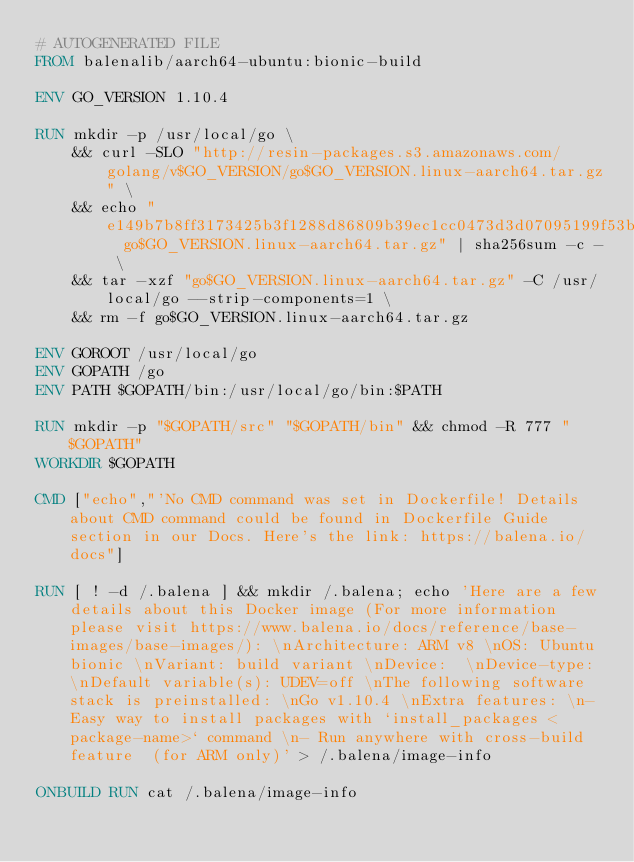Convert code to text. <code><loc_0><loc_0><loc_500><loc_500><_Dockerfile_># AUTOGENERATED FILE
FROM balenalib/aarch64-ubuntu:bionic-build

ENV GO_VERSION 1.10.4

RUN mkdir -p /usr/local/go \
	&& curl -SLO "http://resin-packages.s3.amazonaws.com/golang/v$GO_VERSION/go$GO_VERSION.linux-aarch64.tar.gz" \
	&& echo "e149b7b8ff3173425b3f1288d86809b39ec1cc0473d3d07095199f53bc02ff48  go$GO_VERSION.linux-aarch64.tar.gz" | sha256sum -c - \
	&& tar -xzf "go$GO_VERSION.linux-aarch64.tar.gz" -C /usr/local/go --strip-components=1 \
	&& rm -f go$GO_VERSION.linux-aarch64.tar.gz

ENV GOROOT /usr/local/go
ENV GOPATH /go
ENV PATH $GOPATH/bin:/usr/local/go/bin:$PATH

RUN mkdir -p "$GOPATH/src" "$GOPATH/bin" && chmod -R 777 "$GOPATH"
WORKDIR $GOPATH

CMD ["echo","'No CMD command was set in Dockerfile! Details about CMD command could be found in Dockerfile Guide section in our Docs. Here's the link: https://balena.io/docs"]

RUN [ ! -d /.balena ] && mkdir /.balena; echo 'Here are a few details about this Docker image (For more information please visit https://www.balena.io/docs/reference/base-images/base-images/): \nArchitecture: ARM v8 \nOS: Ubuntu bionic \nVariant: build variant \nDevice:  \nDevice-type: \nDefault variable(s): UDEV=off \nThe following software stack is preinstalled: \nGo v1.10.4 \nExtra features: \n- Easy way to install packages with `install_packages <package-name>` command \n- Run anywhere with cross-build feature  (for ARM only)' > /.balena/image-info

ONBUILD RUN cat /.balena/image-info</code> 